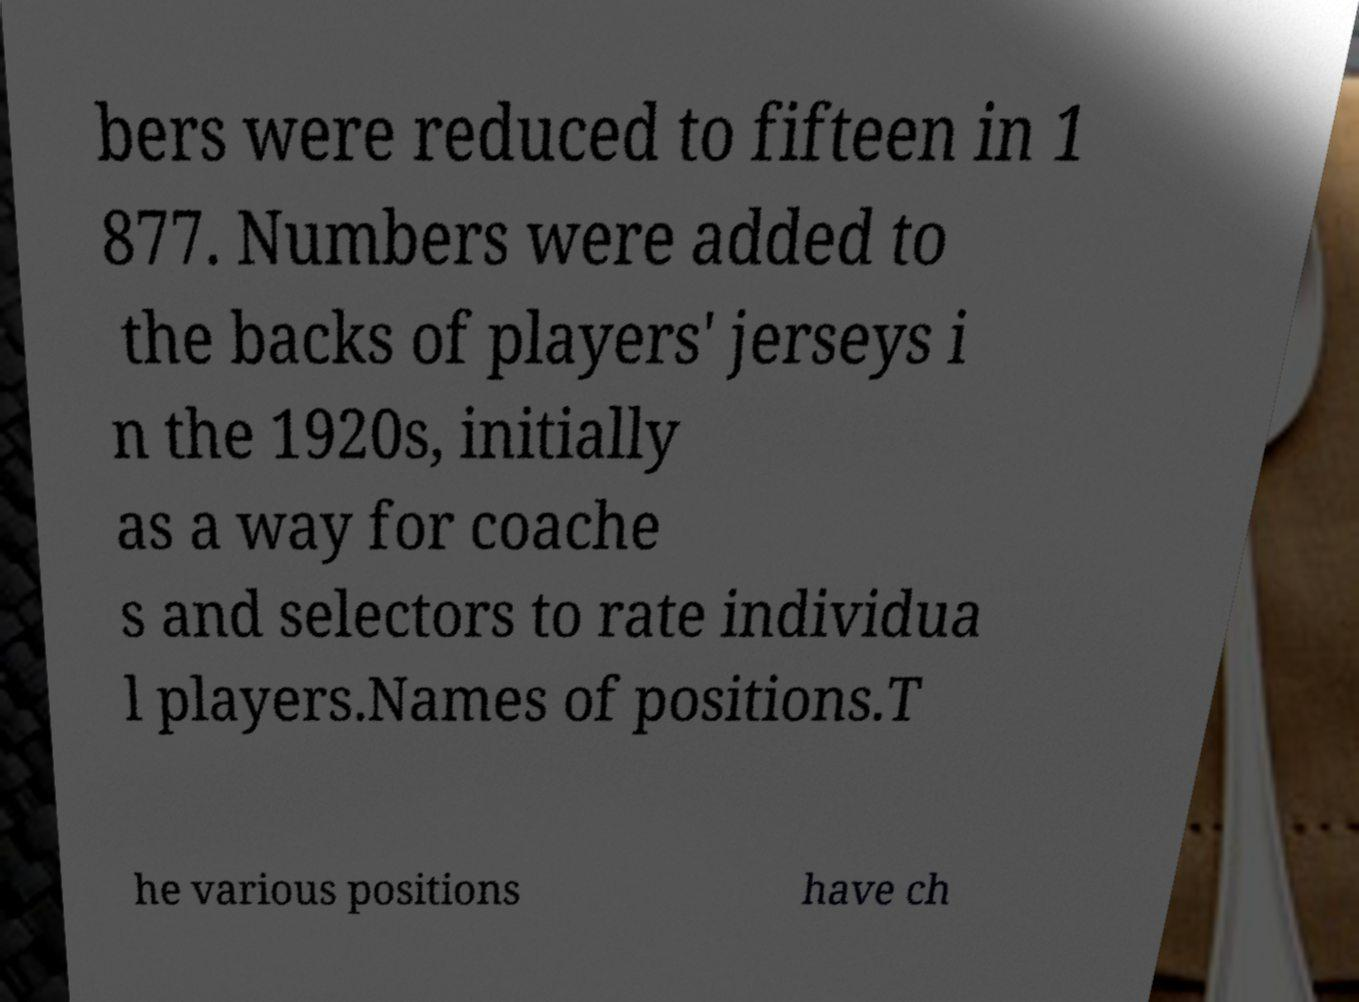Can you accurately transcribe the text from the provided image for me? bers were reduced to fifteen in 1 877. Numbers were added to the backs of players' jerseys i n the 1920s, initially as a way for coache s and selectors to rate individua l players.Names of positions.T he various positions have ch 